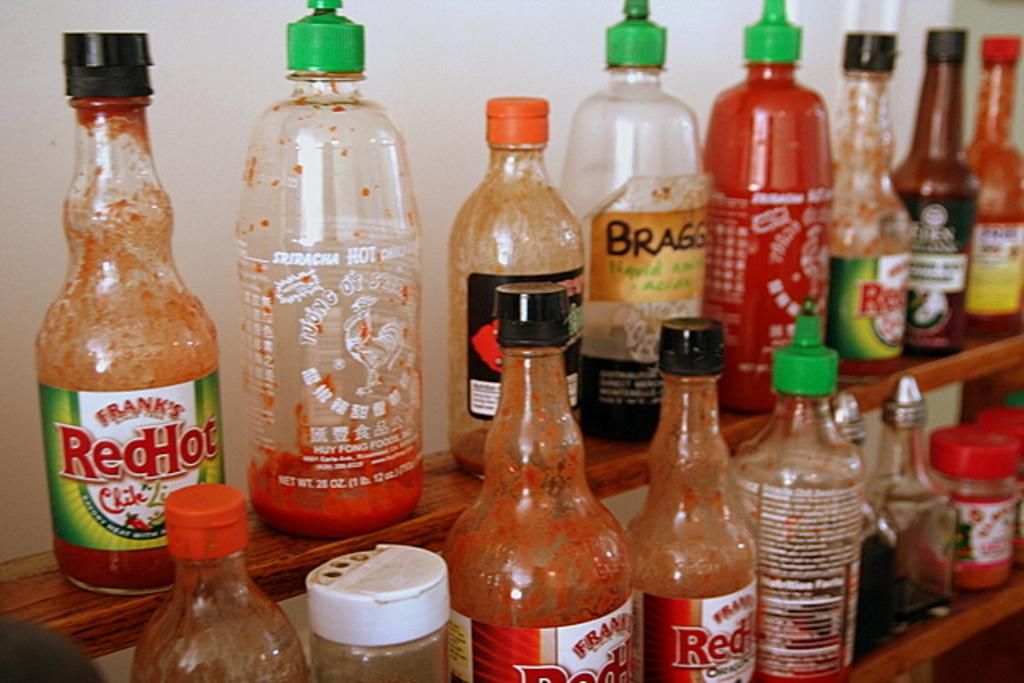<image>
Write a terse but informative summary of the picture. selection of hot sauce including Frank's Red Hot 